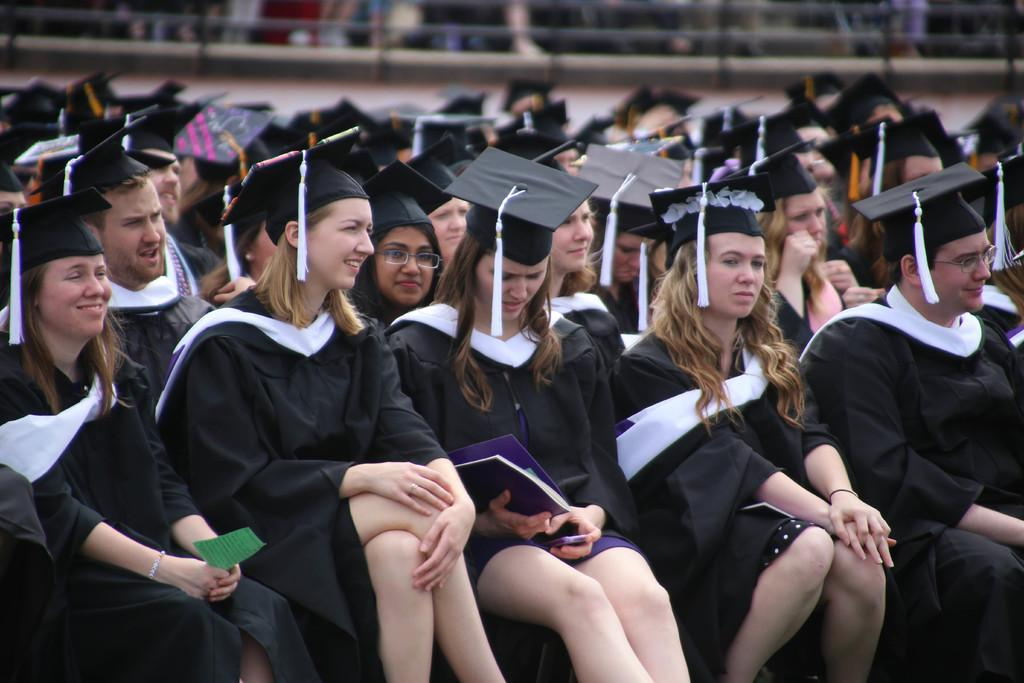What are the people in the image doing? There is a group of people sitting in the image. What are the people wearing on their heads? The people are wearing caps. What objects are being held by the people in the image? One person is holding a book, and another person is holding a mobile. What can be seen in the background of the image? There is a wall in the background of the image. What type of pear can be seen in the image? There is no pear present in the image. Is the group of people in the image a sports team? The facts provided do not mention anything about the group being a sports team, so we cannot definitively answer that question. 